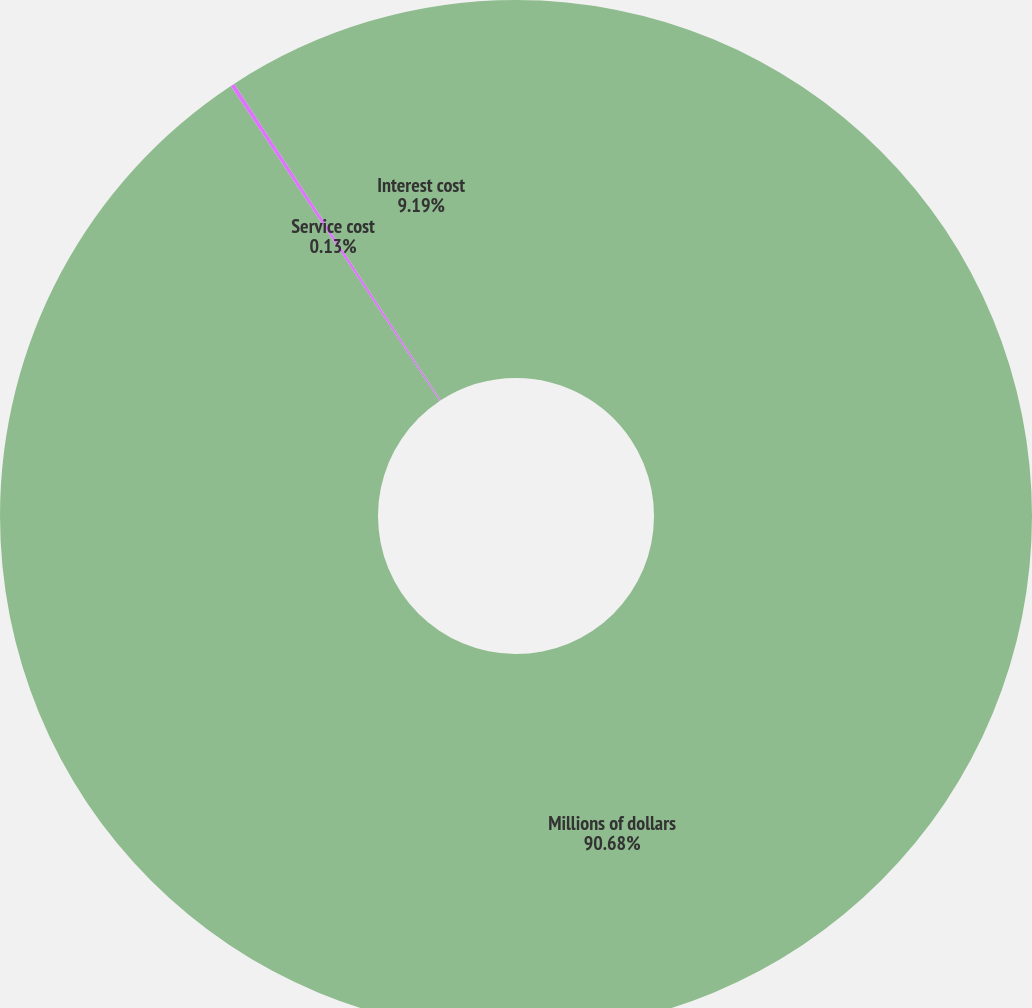Convert chart. <chart><loc_0><loc_0><loc_500><loc_500><pie_chart><fcel>Millions of dollars<fcel>Service cost<fcel>Interest cost<nl><fcel>90.68%<fcel>0.13%<fcel>9.19%<nl></chart> 